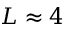<formula> <loc_0><loc_0><loc_500><loc_500>L \approx 4</formula> 